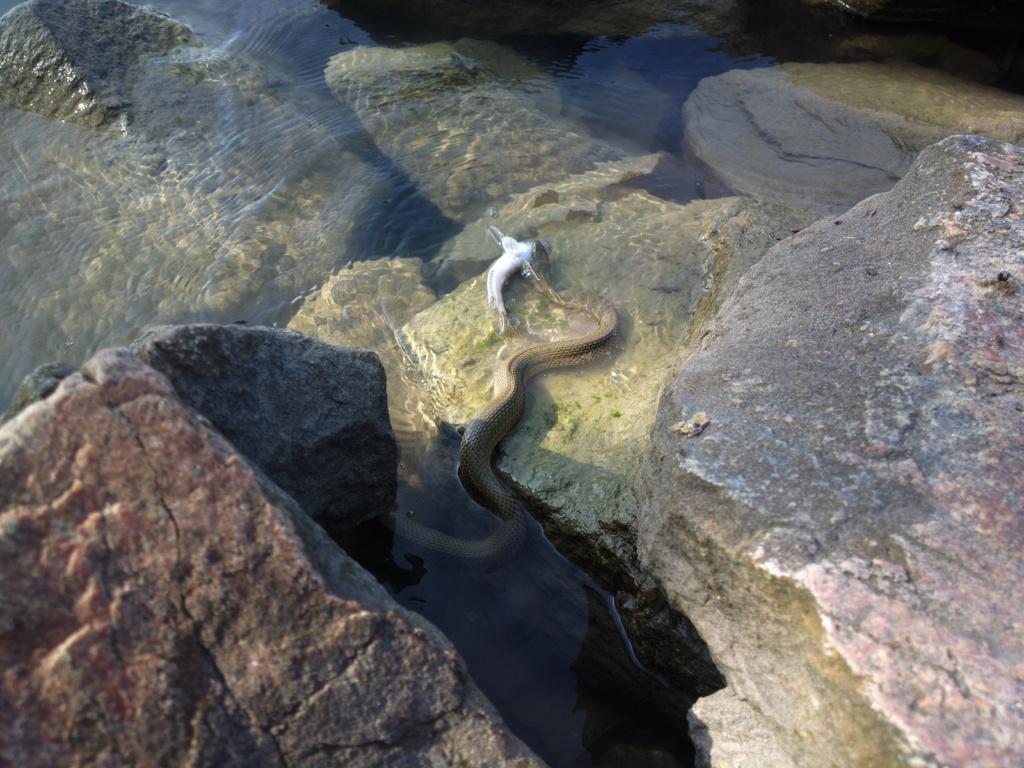Describe this image in one or two sentences. In the center of the image we can see snake holding fish in the water. On the right and left side of the image we can see rocks. 